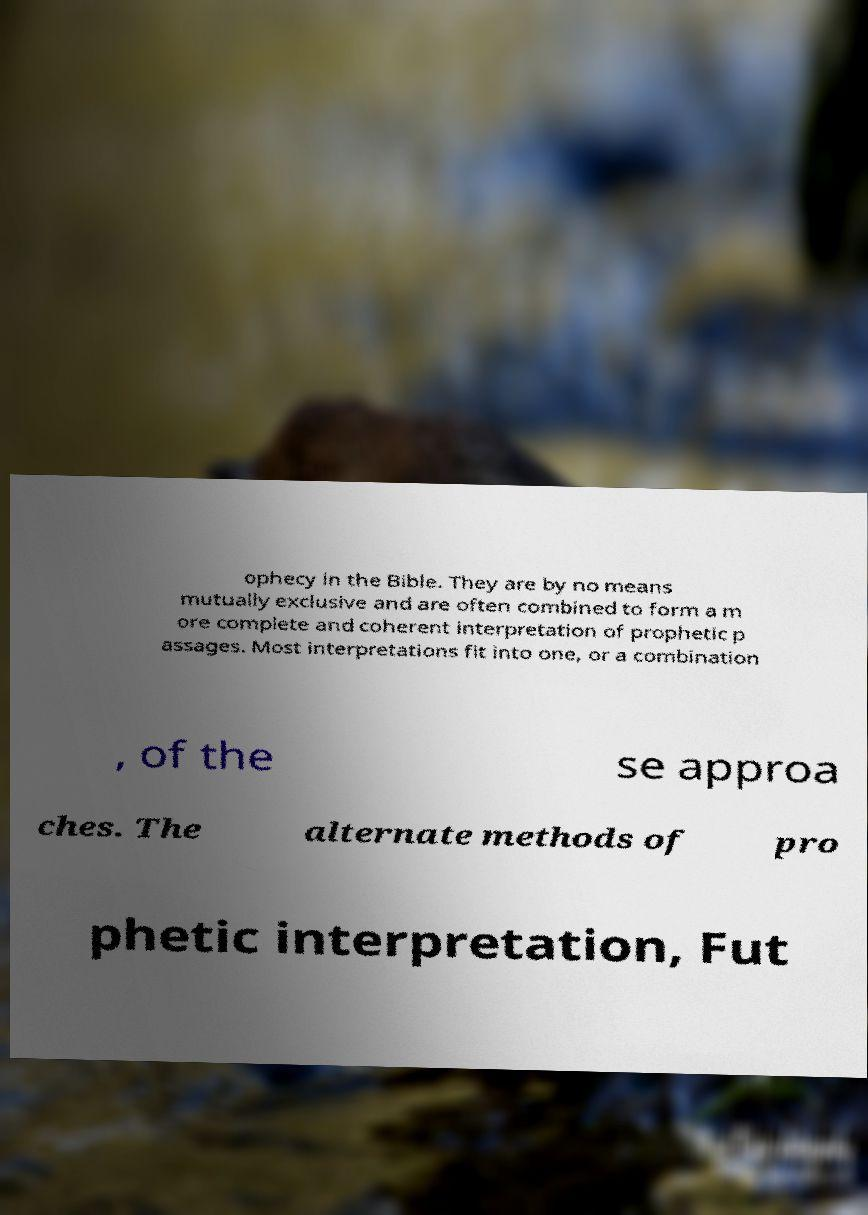Could you assist in decoding the text presented in this image and type it out clearly? ophecy in the Bible. They are by no means mutually exclusive and are often combined to form a m ore complete and coherent interpretation of prophetic p assages. Most interpretations fit into one, or a combination , of the se approa ches. The alternate methods of pro phetic interpretation, Fut 